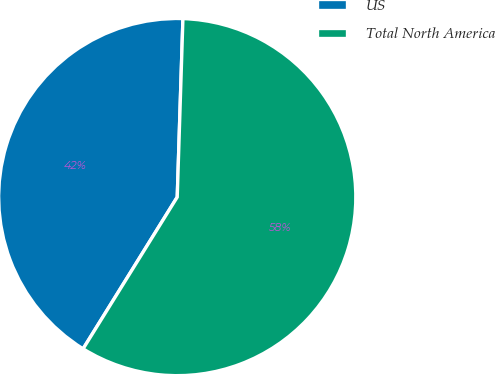Convert chart to OTSL. <chart><loc_0><loc_0><loc_500><loc_500><pie_chart><fcel>US<fcel>Total North America<nl><fcel>41.67%<fcel>58.33%<nl></chart> 